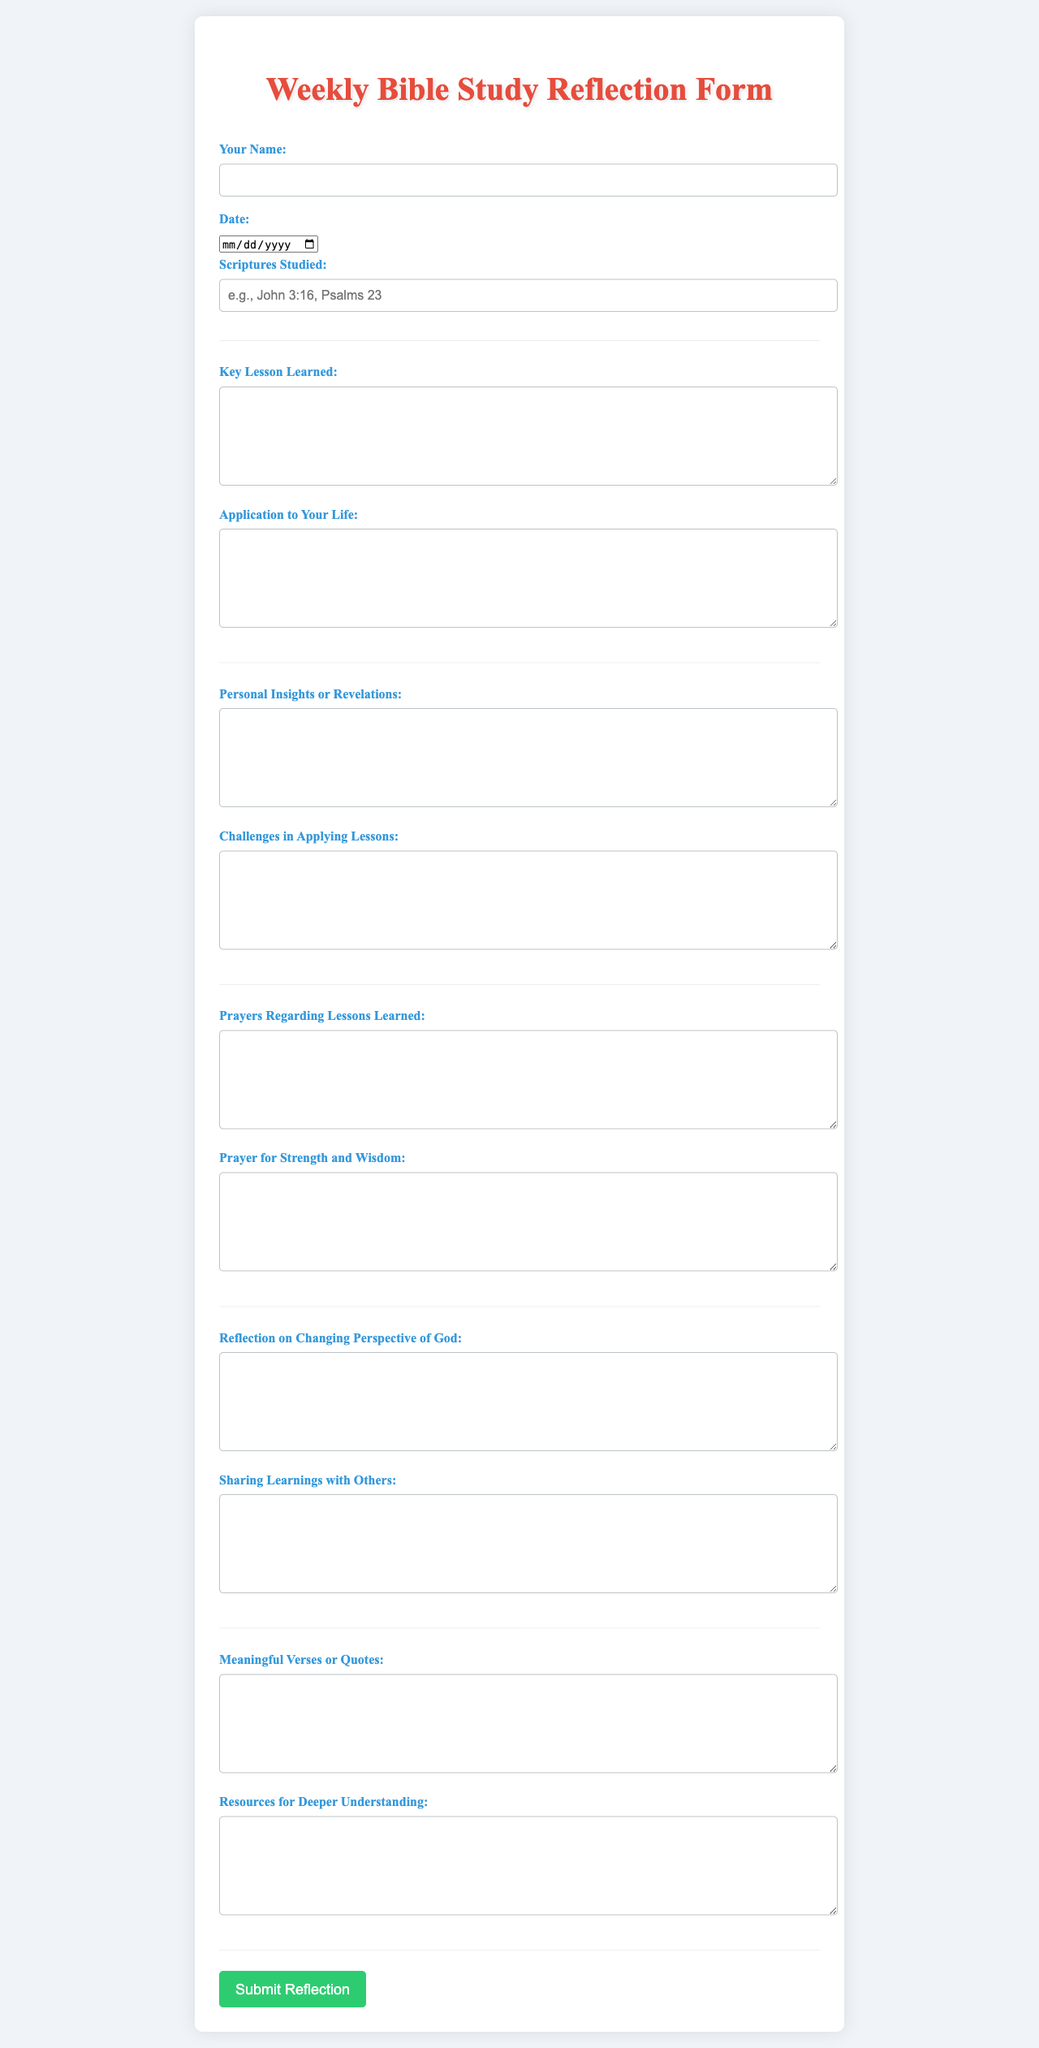What is the title of the form? The title is mentioned prominently at the top of the document, indicating the purpose of the form.
Answer: Weekly Bible Study Reflection Form How many sections are there in the form? The form is divided into multiple sections that address personal insights, prayers, and reflections from Bible study.
Answer: 6 What is required in the “Your Name” field? This field necessitates the participant's name to personalize the reflection form.
Answer: Name What type of input is required for “Scriptures Studied”? This input requests a textual representation of the scriptures the participant has studied during the week.
Answer: Text What is asked for in the “Key Lesson Learned” section? This section specifically asks participants to describe the significant lesson they have drawn from the scriptures.
Answer: Key Lesson Learned What is the color of the submit button? The color of the submit button indicates its functionality visually and draws attention for action.
Answer: Green What does the last section in the form focus on? The last section is dedicated to capturing meaningful verses and resources that could deepen understanding.
Answer: Meaningful Verses or Quotes What is encouraged in the “Sharing Learnings with Others” field? This field encourages participants to reflect on how they can communicate their insights to others, fostering a communal exchange of knowledge.
Answer: Sharing Learnings with Others 